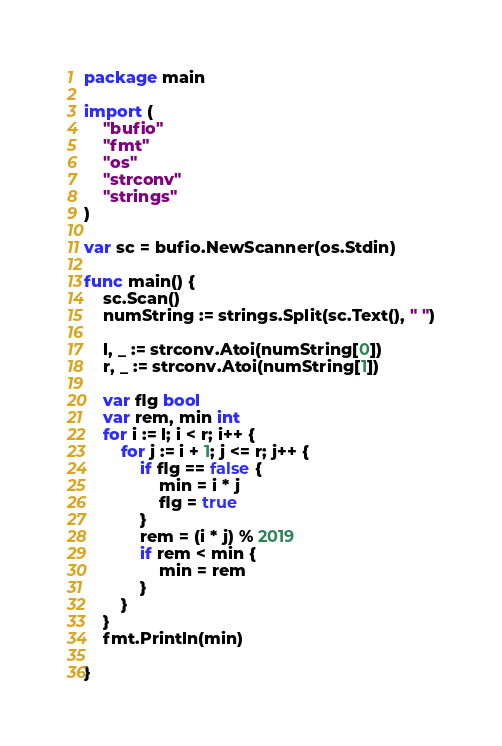Convert code to text. <code><loc_0><loc_0><loc_500><loc_500><_Go_>package main

import (
	"bufio"
	"fmt"
	"os"
	"strconv"
	"strings"
)

var sc = bufio.NewScanner(os.Stdin)

func main() {
	sc.Scan()
	numString := strings.Split(sc.Text(), " ")

	l, _ := strconv.Atoi(numString[0])
	r, _ := strconv.Atoi(numString[1])

	var flg bool
	var rem, min int
	for i := l; i < r; i++ {
		for j := i + 1; j <= r; j++ {
			if flg == false {
				min = i * j
				flg = true
			}
			rem = (i * j) % 2019
			if rem < min {
				min = rem
			}
		}
	}
	fmt.Println(min)

}</code> 